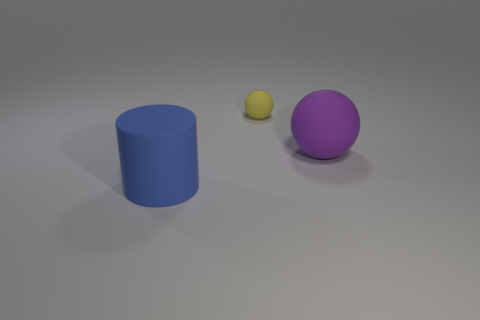There is a large thing left of the rubber thing that is behind the matte object to the right of the small yellow rubber ball; what color is it? The large object to the left of the rubber thing, which in this context is the small yellow rubber ball positioned to the right of the blue matte cylinder, is indeed a purple sphere. 